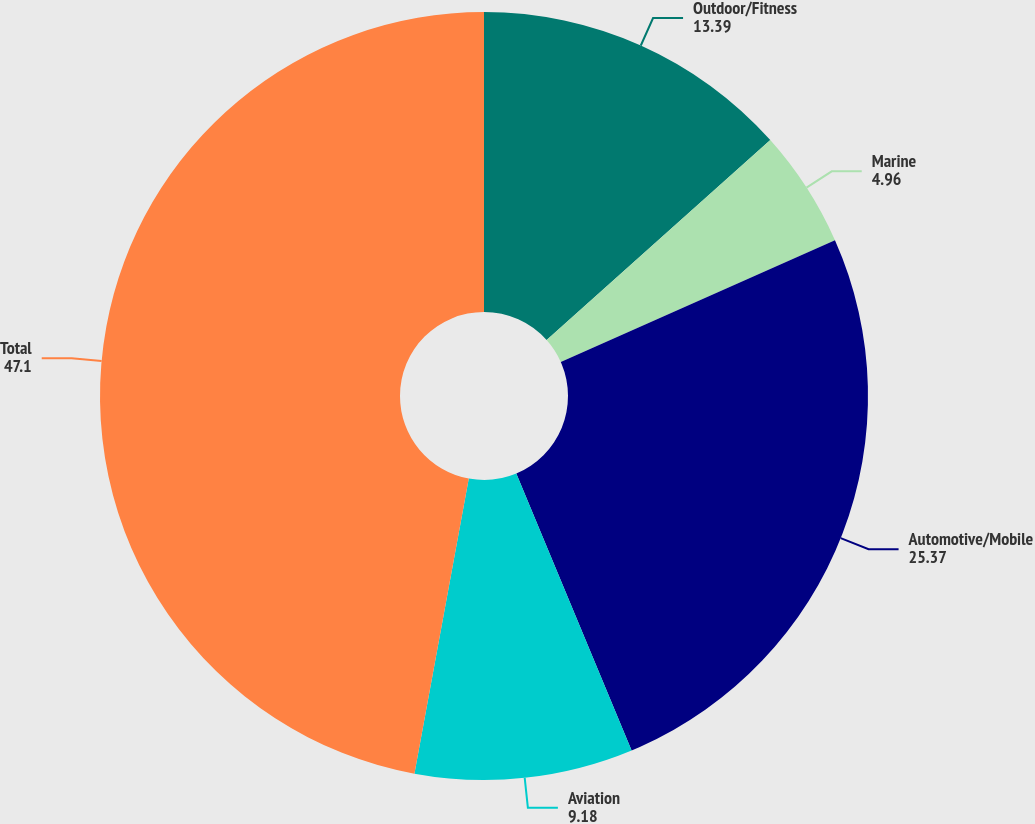<chart> <loc_0><loc_0><loc_500><loc_500><pie_chart><fcel>Outdoor/Fitness<fcel>Marine<fcel>Automotive/Mobile<fcel>Aviation<fcel>Total<nl><fcel>13.39%<fcel>4.96%<fcel>25.37%<fcel>9.18%<fcel>47.1%<nl></chart> 